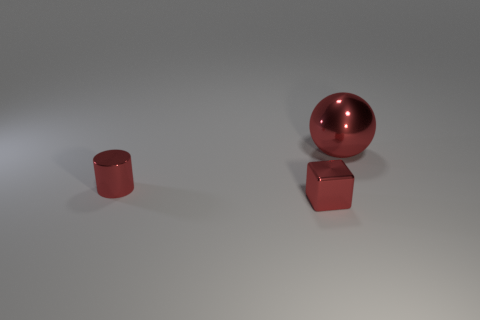Is the size of the object that is on the right side of the small metallic block the same as the red thing to the left of the small cube?
Offer a terse response. No. There is a shiny ball; is its size the same as the red thing that is in front of the cylinder?
Provide a short and direct response. No. There is a tiny block that is to the right of the metal cylinder; is there a tiny cylinder that is to the right of it?
Your response must be concise. No. There is a small red metal thing in front of the red cylinder; what shape is it?
Give a very brief answer. Cube. There is a tiny object that is the same color as the cylinder; what is its material?
Make the answer very short. Metal. There is a tiny metal thing on the right side of the thing left of the metallic cube; what color is it?
Your answer should be compact. Red. Do the shiny ball and the red cylinder have the same size?
Provide a short and direct response. No. What number of things have the same size as the shiny cube?
Provide a short and direct response. 1. The cylinder that is made of the same material as the small red block is what color?
Make the answer very short. Red. Are there fewer big metal spheres than large gray balls?
Provide a short and direct response. No. 